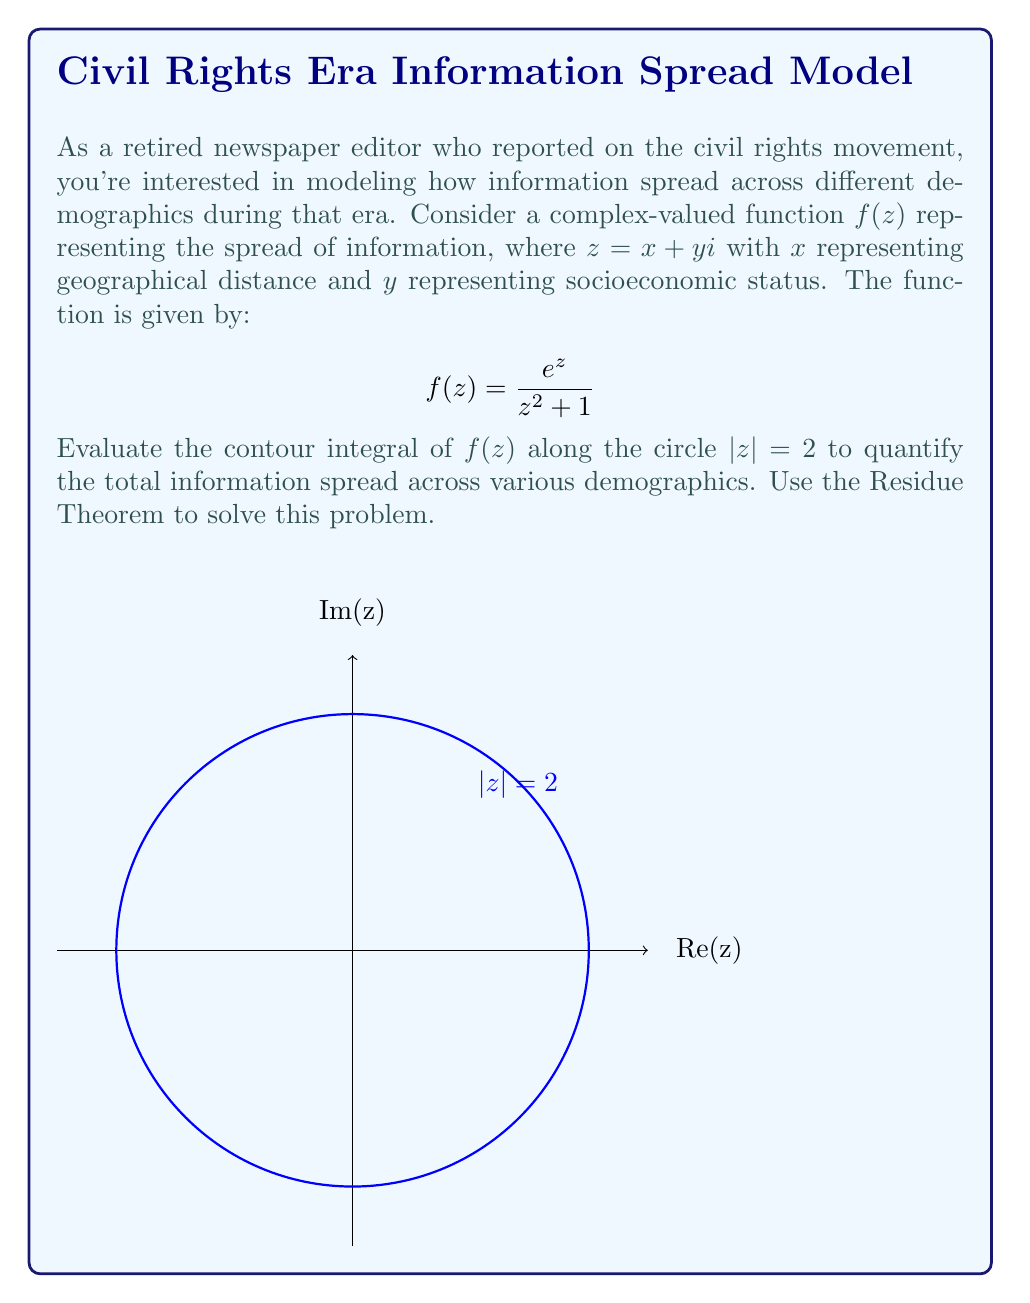Can you answer this question? To solve this problem using the Residue Theorem, we'll follow these steps:

1) The Residue Theorem states that for a function $f(z)$ that is analytic inside and on a simple closed curve $C$, except at a finite number of singular points inside $C$:

   $$\oint_C f(z) dz = 2\pi i \sum_{k=1}^n \text{Res}(f, a_k)$$

   where $a_k$ are the singular points of $f(z)$ inside $C$.

2) In our case, $C$ is the circle $|z| = 2$. We need to find the singularities of $f(z)$ inside this circle.

3) The singularities of $f(z)$ occur when $z^2 + 1 = 0$, i.e., when $z = \pm i$.

4) Only $z = i$ is inside the contour $|z| = 2$.

5) To find the residue at $z = i$, we use the formula for a simple pole:

   $$\text{Res}(f, i) = \lim_{z \to i} (z-i)f(z) = \lim_{z \to i} \frac{(z-i)e^z}{z^2 + 1}$$

6) Applying L'Hôpital's rule:

   $$\text{Res}(f, i) = \lim_{z \to i} \frac{e^z + (z-i)e^z}{2z} = \frac{e^i + 0}{2i} = \frac{e^i}{2i}$$

7) Now we can apply the Residue Theorem:

   $$\oint_{|z|=2} f(z) dz = 2\pi i \cdot \frac{e^i}{2i} = \pi e^i$$

This complex number represents the total information spread, with its magnitude indicating the extent of spread and its argument indicating the dominant direction or demographic of spread.
Answer: $\pi e^i$ 